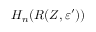<formula> <loc_0><loc_0><loc_500><loc_500>H _ { n } ( R ( Z , \varepsilon ^ { \prime } ) )</formula> 